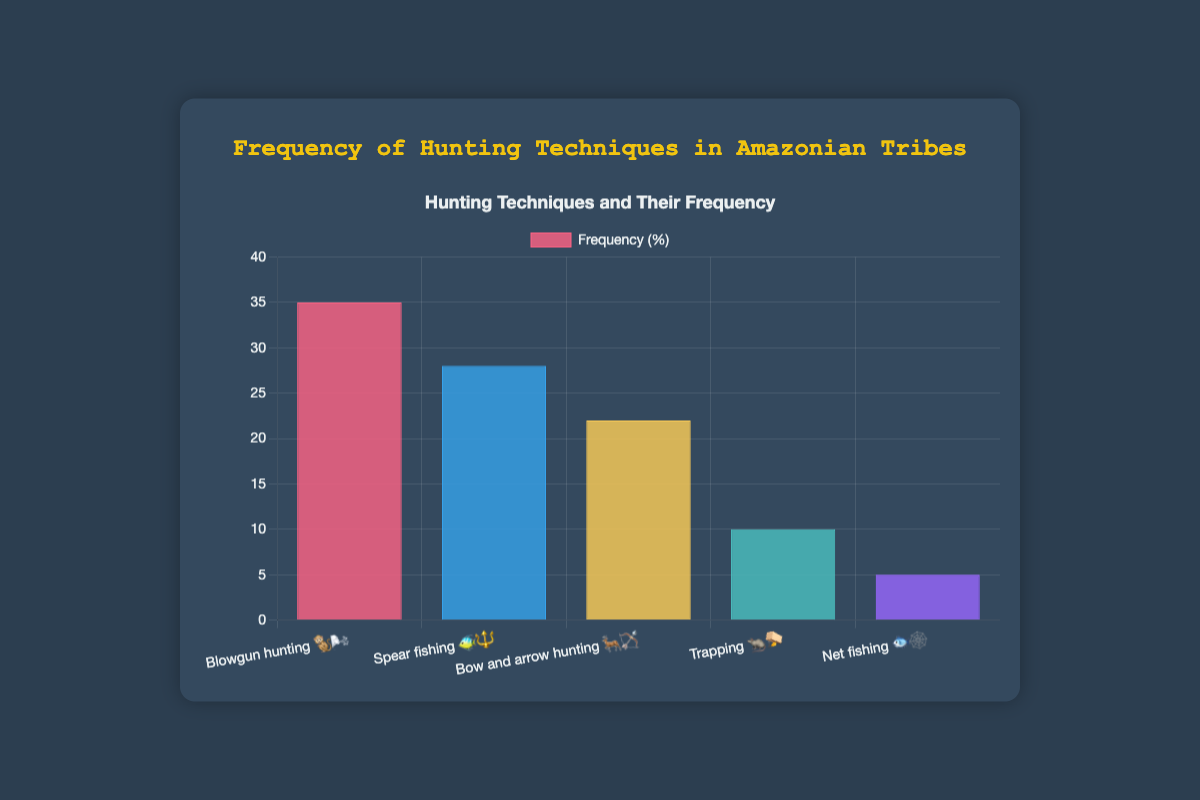How is the frequency of 🌬️ Blowgun hunting 🐒 compared to 🔱 Spear fishing 🐠? First, identify the frequency of 🌬️ Blowgun hunting 🐒 which is 35. Then, identify the frequency of 🔱 Spear fishing 🐠 which is 28. Compare the two values: 35 is greater than 28.
Answer: 🌬️ Blowgun hunting 🐒 is more frequent than 🔱 Spear fishing 🐠 Which hunting technique has the highest frequency? Look at the frequencies of all hunting techniques and find the highest one: 🌬️ Blowgun hunting 🐒 with a frequency of 35.
Answer: 🌬️ Blowgun hunting 🐒 What is the sum of the frequencies of 🏹 Bow and arrow hunting 🦌 and 🪤 Trapping 🐀? First, find the frequency of 🏹 Bow and arrow hunting 🦌 which is 22. Then, find the frequency of 🪤 Trapping 🐀 which is 10. Add these two values: 22 + 10 = 32.
Answer: 32 How much less frequent is 🪤 Trapping 🐀 compared to 🔱 Spear fishing 🐠? First, find the frequency of 🪤 Trapping 🐀 which is 10. Then, find the frequency of 🔱 Spear fishing 🐠 which is 28. Subtract the two values: 28 - 10 = 18.
Answer: 18 Which hunting technique is the least frequent? Look at the frequencies of all hunting techniques and find the lowest one: 🕸️ Net fishing 🐟 with a frequency of 5.
Answer: 🕸️ Net fishing 🐟 What is the average frequency of all the hunting techniques? First, sum all the frequencies: 35 (🌬️ Blowgun hunting 🐒) + 28 (🔱 Spear fishing 🐠) + 22 (🏹 Bow and arrow hunting 🦌) + 10 (🪤 Trapping 🐀) + 5 (🕸️ Net fishing 🐟) = 100. Then, divide by the number of techniques, which is 5: 100 / 5 = 20.
Answer: 20 Is the frequency of 🪤 Trapping 🐀 more than or equal to one-third of 🌬️ Blowgun hunting 🐒? Calculate one-third of the frequency of 🌬️ Blowgun hunting 🐒: 35 / 3 ≈ 11.67. Compare this value with the frequency of 🪤 Trapping 🐀 which is 10. 10 is less than 11.67, so it is not more than or equal.
Answer: No 